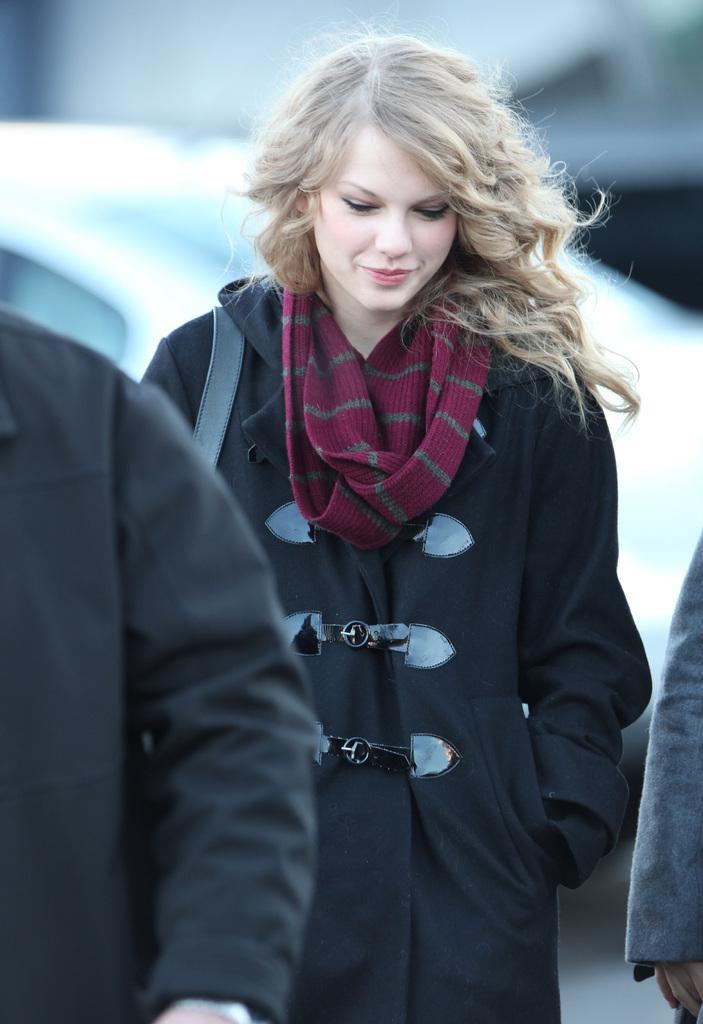Can you describe this image briefly? There is a woman standing and smiling and we can see persons hands. Background we can see car. 